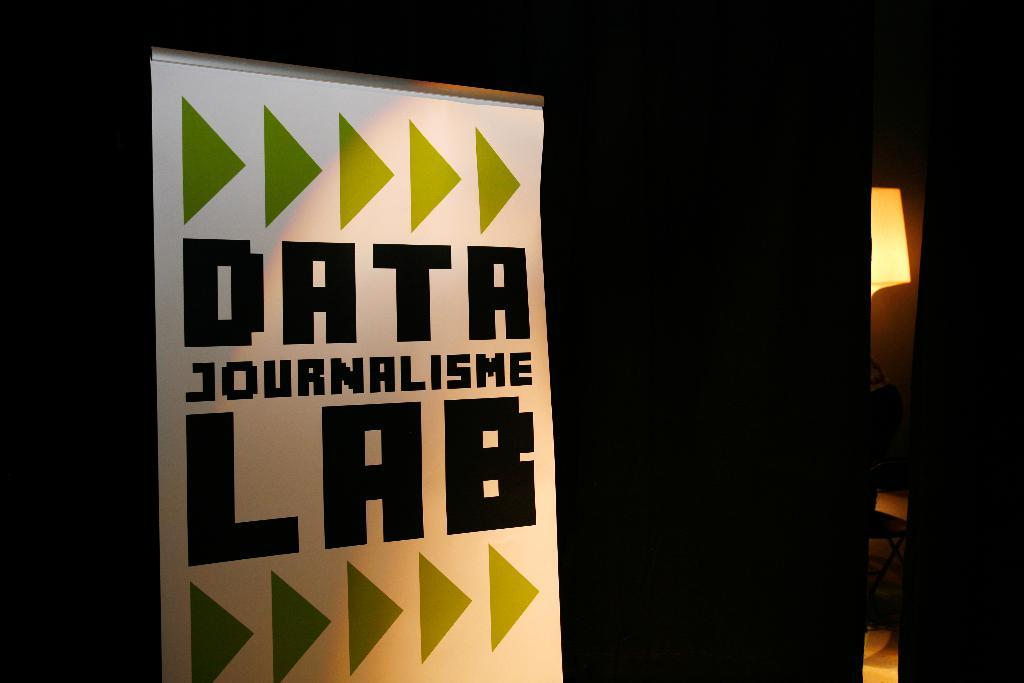<image>
Give a short and clear explanation of the subsequent image. A directional sign pointing towards the Data Journalisme Lab. 